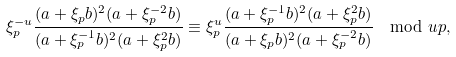Convert formula to latex. <formula><loc_0><loc_0><loc_500><loc_500>\xi _ { p } ^ { - u } \frac { ( a + \xi _ { p } b ) ^ { 2 } ( a + \xi _ { p } ^ { - 2 } b ) } { ( a + \xi _ { p } ^ { - 1 } b ) ^ { 2 } ( a + \xi _ { p } ^ { 2 } b ) } \equiv \xi _ { p } ^ { u } \frac { ( a + \xi _ { p } ^ { - 1 } b ) ^ { 2 } ( a + \xi _ { p } ^ { 2 } b ) } { ( a + \xi _ { p } b ) ^ { 2 } ( a + \xi _ { p } ^ { - 2 } b ) } \mod u p ,</formula> 